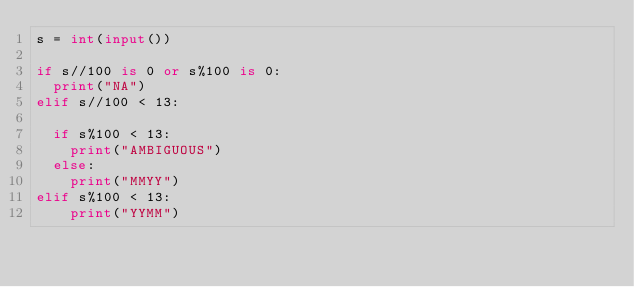Convert code to text. <code><loc_0><loc_0><loc_500><loc_500><_Python_>s = int(input())

if s//100 is 0 or s%100 is 0:
  print("NA")
elif s//100 < 13:
  
  if s%100 < 13:
    print("AMBIGUOUS")
  else:
    print("MMYY")
elif s%100 < 13:
    print("YYMM")
</code> 